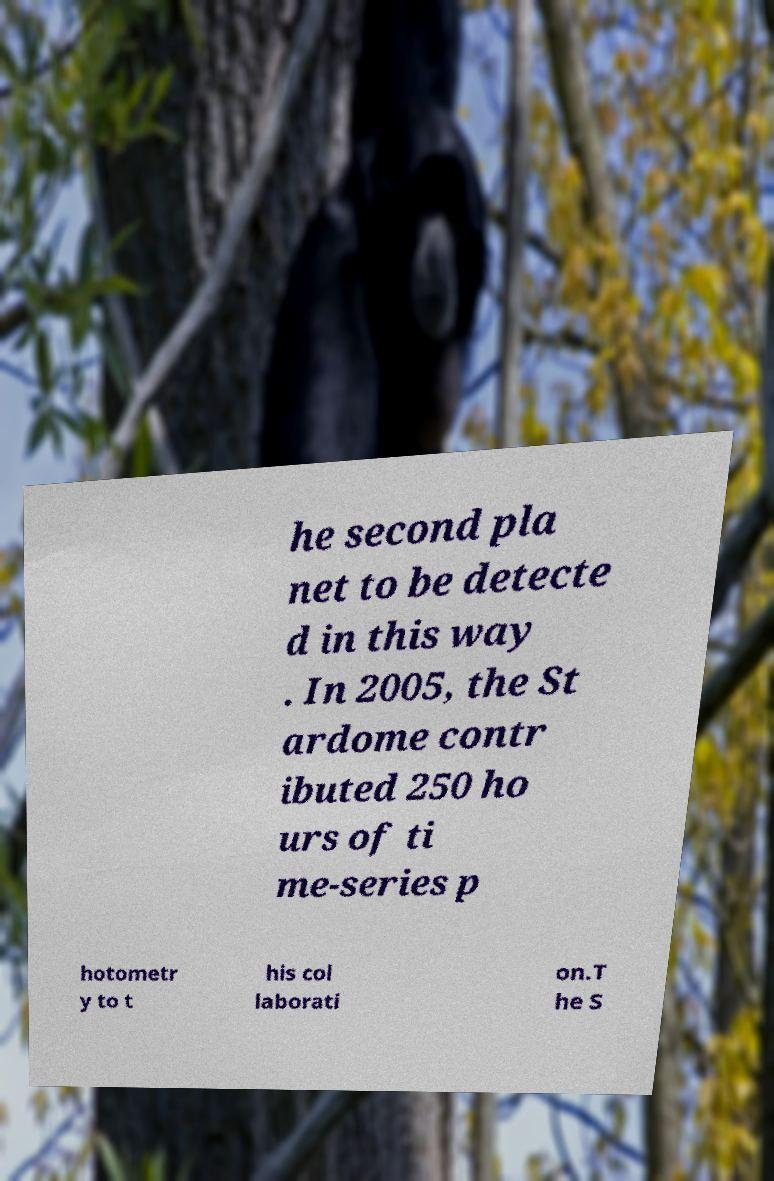Please identify and transcribe the text found in this image. he second pla net to be detecte d in this way . In 2005, the St ardome contr ibuted 250 ho urs of ti me-series p hotometr y to t his col laborati on.T he S 